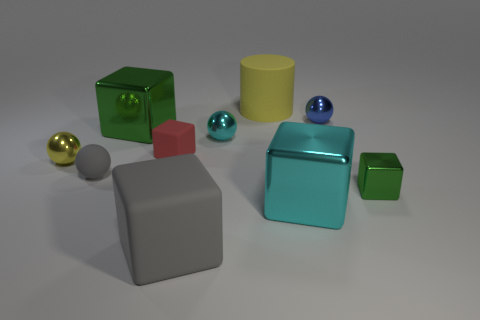Subtract all blue balls. How many balls are left? 3 Subtract all rubber blocks. How many blocks are left? 3 Subtract all balls. How many objects are left? 6 Subtract all cyan spheres. Subtract all brown cubes. How many spheres are left? 3 Subtract all yellow balls. How many green blocks are left? 2 Subtract all small gray matte objects. Subtract all yellow rubber things. How many objects are left? 8 Add 1 yellow shiny things. How many yellow shiny things are left? 2 Add 1 blue rubber spheres. How many blue rubber spheres exist? 1 Subtract 0 red cylinders. How many objects are left? 10 Subtract 1 spheres. How many spheres are left? 3 